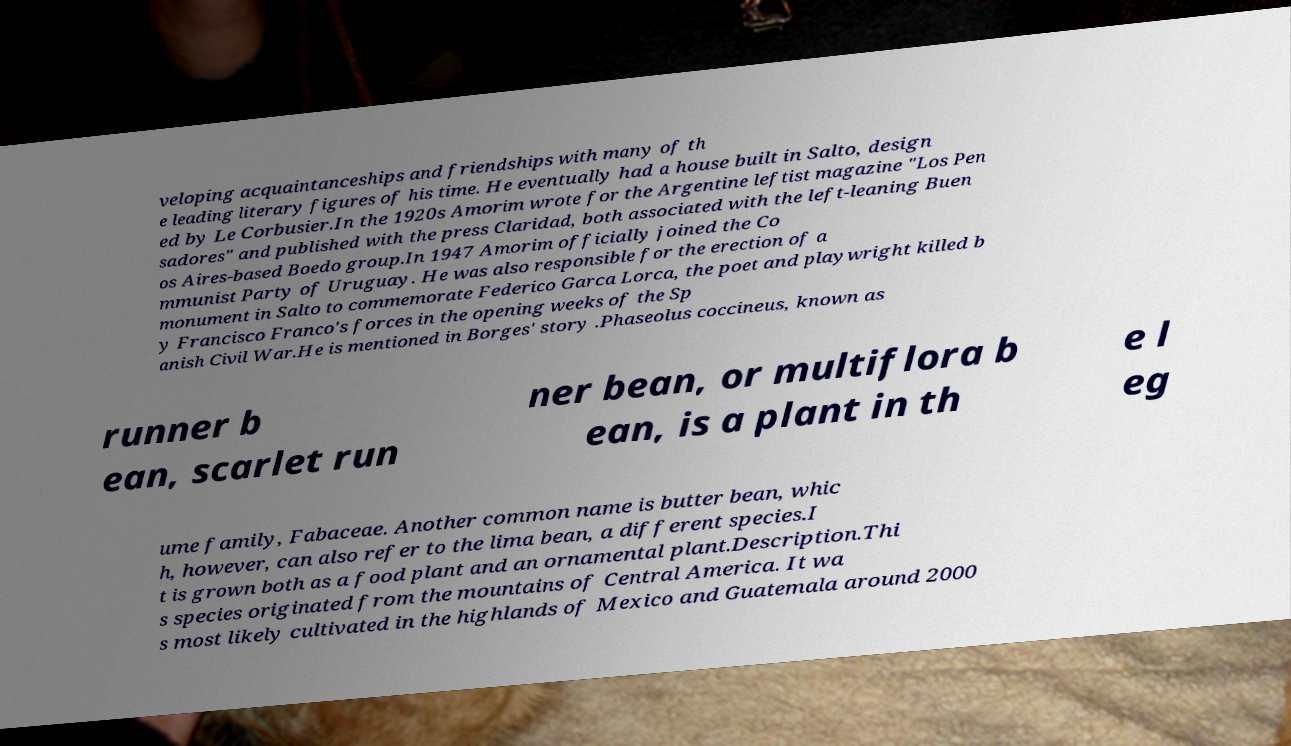There's text embedded in this image that I need extracted. Can you transcribe it verbatim? veloping acquaintanceships and friendships with many of th e leading literary figures of his time. He eventually had a house built in Salto, design ed by Le Corbusier.In the 1920s Amorim wrote for the Argentine leftist magazine "Los Pen sadores" and published with the press Claridad, both associated with the left-leaning Buen os Aires-based Boedo group.In 1947 Amorim officially joined the Co mmunist Party of Uruguay. He was also responsible for the erection of a monument in Salto to commemorate Federico Garca Lorca, the poet and playwright killed b y Francisco Franco's forces in the opening weeks of the Sp anish Civil War.He is mentioned in Borges' story .Phaseolus coccineus, known as runner b ean, scarlet run ner bean, or multiflora b ean, is a plant in th e l eg ume family, Fabaceae. Another common name is butter bean, whic h, however, can also refer to the lima bean, a different species.I t is grown both as a food plant and an ornamental plant.Description.Thi s species originated from the mountains of Central America. It wa s most likely cultivated in the highlands of Mexico and Guatemala around 2000 